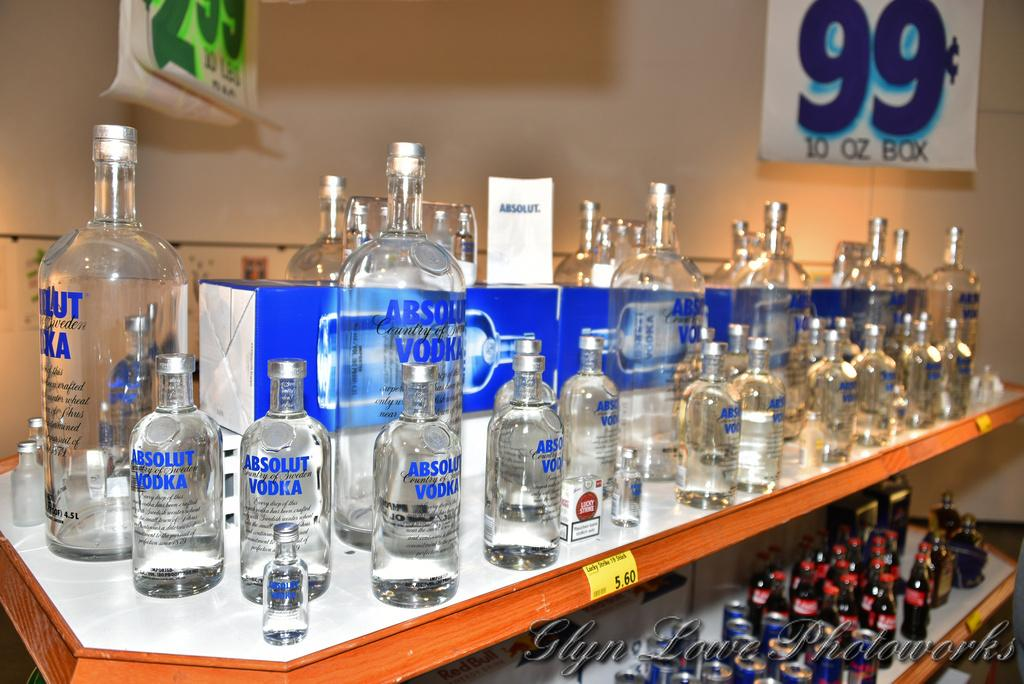<image>
Summarize the visual content of the image. A sign for 99 cents rests behind clear bottles 